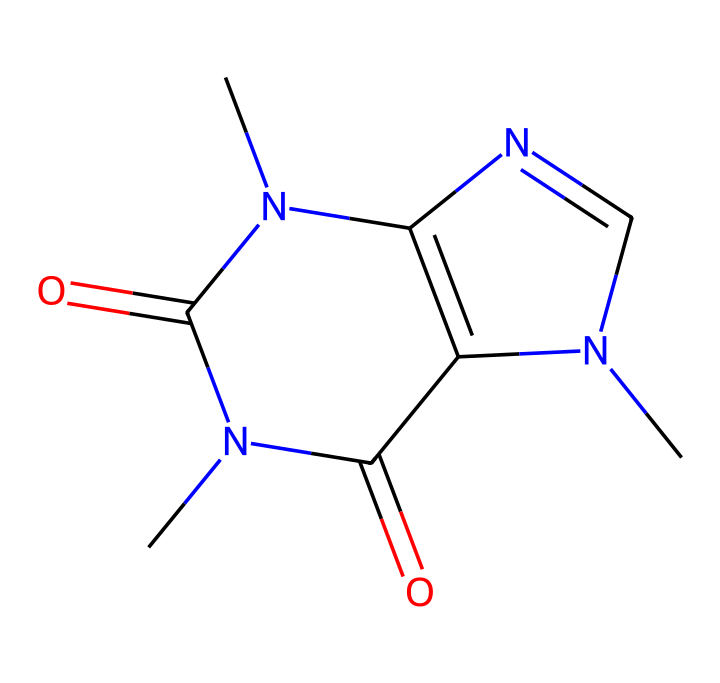What is the molecular formula of caffeine? The molecular formula can be derived from the SMILES structure by identifying the number and type of atoms present. In the structure, we can count 8 Carbon atoms, 10 Hydrogen atoms, 4 Nitrogen atoms, and 2 Oxygen atoms, which gives us the molecular formula C8H10N4O2.
Answer: C8H10N4O2 How many nitrogen atoms are in caffeine? By analyzing the SMILES representation, we can identify the number of nitrogen atoms (N). There are 4 occurrences of nitrogen in the structure, leading to the conclusion that caffeine contains 4 nitrogen atoms.
Answer: 4 Is caffeine a polar or non-polar compound? Caffeine contains polar functional groups (such as the carbonyl groups) and nitrogen atoms that can form hydrogen bonds, making it more polar. However, the overall balance of the molecule suggests it has both polar and non-polar characteristics, but it is mostly considered polar due to these groups.
Answer: polar What type of compound is caffeine? The structure indicates the presence of nitrogen atoms and a carbon framework, characteristic of alkaloids. Caffeine is classified as a psychoactive alkaloid due to its stimulating effects.
Answer: alkaloid What is the number of rings present in the caffeine structure? By examining the SMILES, we notice two cyclic structures where nitrogen is incorporated into the rings. This confirms that caffeine has 2 fused rings in its structure.
Answer: 2 Does caffeine have any functional groups? In the SMILES representation, we can observe carbonyl groups (>C=O) along with nitrogen atoms. These indicate the presence of functional groups, specifically amine and carbonyl functional groups.
Answer: yes How might the presence of nitrogen affect caffeine's properties? The nitrogen atoms in caffeine contribute to its basicity and the ability to form hydrogen bonds, affecting its solubility in water and biological activity, which is relevant to its action as a stimulant.
Answer: increases basicity 